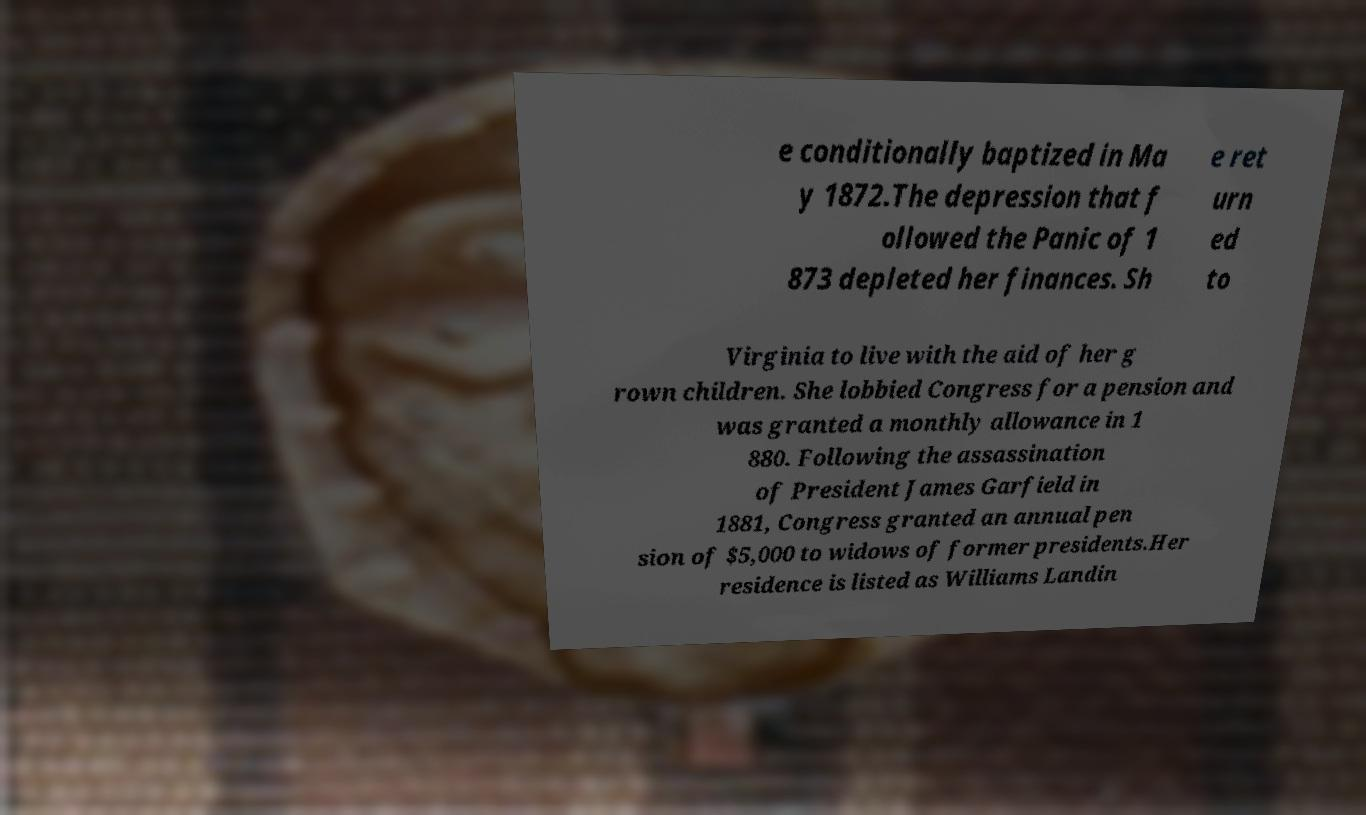Can you accurately transcribe the text from the provided image for me? e conditionally baptized in Ma y 1872.The depression that f ollowed the Panic of 1 873 depleted her finances. Sh e ret urn ed to Virginia to live with the aid of her g rown children. She lobbied Congress for a pension and was granted a monthly allowance in 1 880. Following the assassination of President James Garfield in 1881, Congress granted an annual pen sion of $5,000 to widows of former presidents.Her residence is listed as Williams Landin 